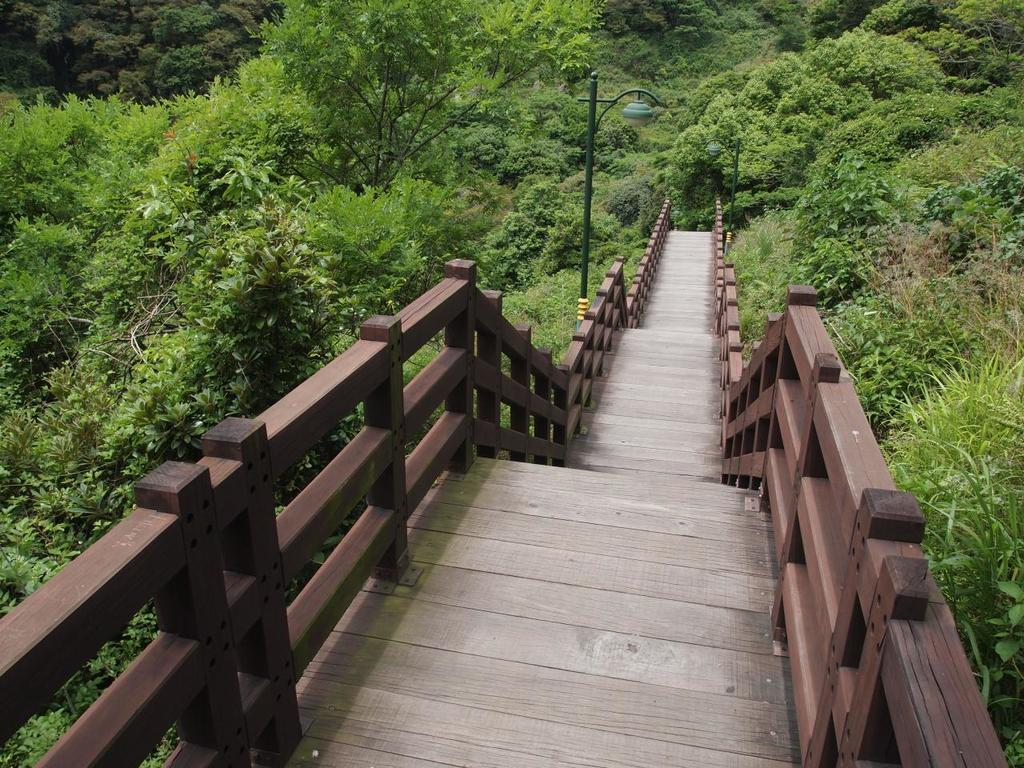What type of structure is present in the image? There is a wooden bridge in the image. What can be seen on both sides of the bridge? There are plants and trees on both sides of the bridge. What are the poles with lights used for in the image? The poles with lights are likely used for illuminating the bridge and its surroundings. What type of cabbage can be seen growing on the bridge in the image? There is no cabbage present on the bridge in the image. What color is the linen draped over the trees in the image? There is no linen draped over the trees in the image. 